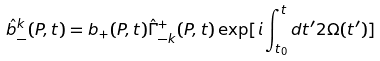Convert formula to latex. <formula><loc_0><loc_0><loc_500><loc_500>\hat { b } _ { - } ^ { k } ( P , t ) = b _ { + } ( P , t ) \hat { \Gamma } _ { - k } ^ { + } ( P , t ) \exp [ i \int _ { t _ { 0 } } ^ { t } d t ^ { \prime } 2 \Omega ( t ^ { \prime } ) ]</formula> 